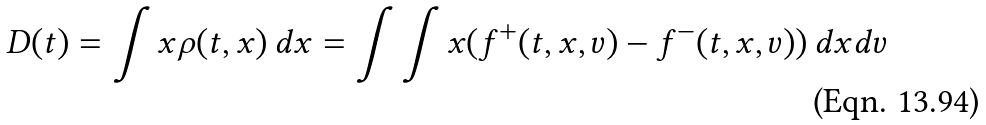<formula> <loc_0><loc_0><loc_500><loc_500>D ( t ) = \int x \rho ( t , x ) \, d x = \int \int x ( f ^ { + } ( t , x , v ) - f ^ { - } ( t , x , v ) ) \, d x d v</formula> 